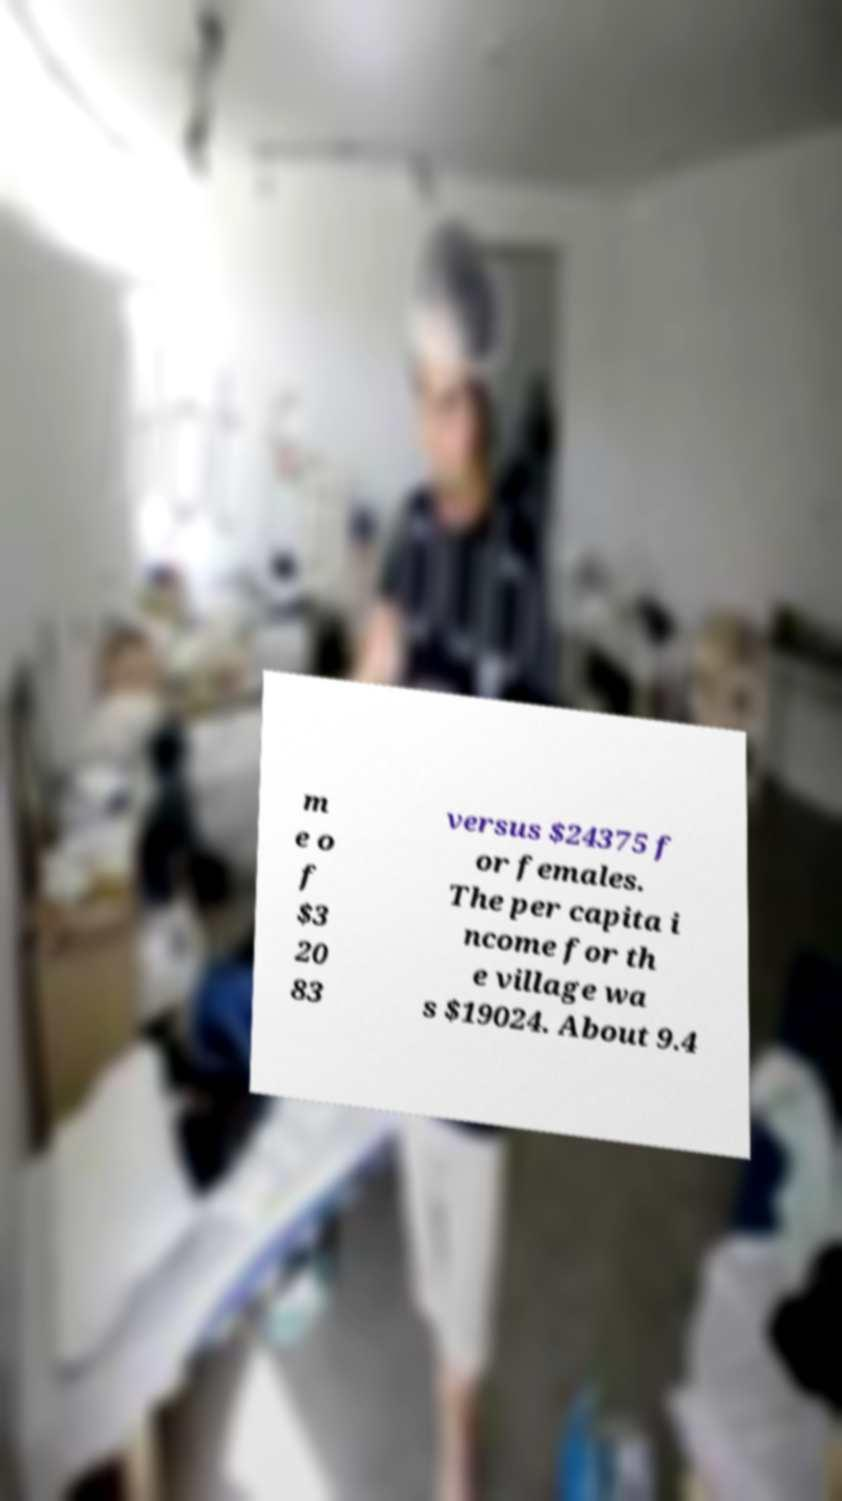For documentation purposes, I need the text within this image transcribed. Could you provide that? m e o f $3 20 83 versus $24375 f or females. The per capita i ncome for th e village wa s $19024. About 9.4 